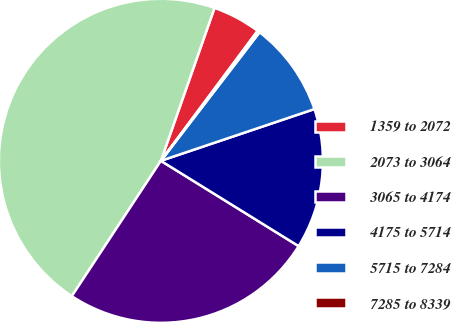Convert chart to OTSL. <chart><loc_0><loc_0><loc_500><loc_500><pie_chart><fcel>1359 to 2072<fcel>2073 to 3064<fcel>3065 to 4174<fcel>4175 to 5714<fcel>5715 to 7284<fcel>7285 to 8339<nl><fcel>4.82%<fcel>46.11%<fcel>25.44%<fcel>14.0%<fcel>9.41%<fcel>0.23%<nl></chart> 